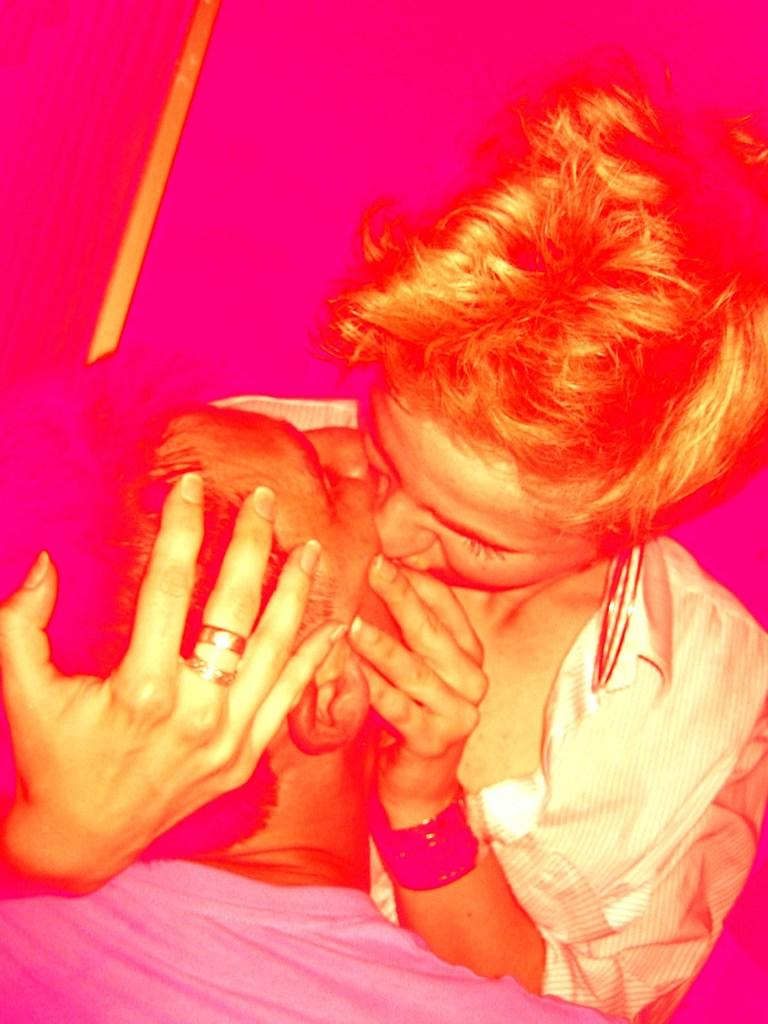How many people are in the image? There are two persons in the image. What are the two persons doing in the image? The two persons are kissing each other. What type of detail can be seen on the person's teeth in the image? There is no visible detail on the person's teeth in the image, as their mouths are closed while kissing. 